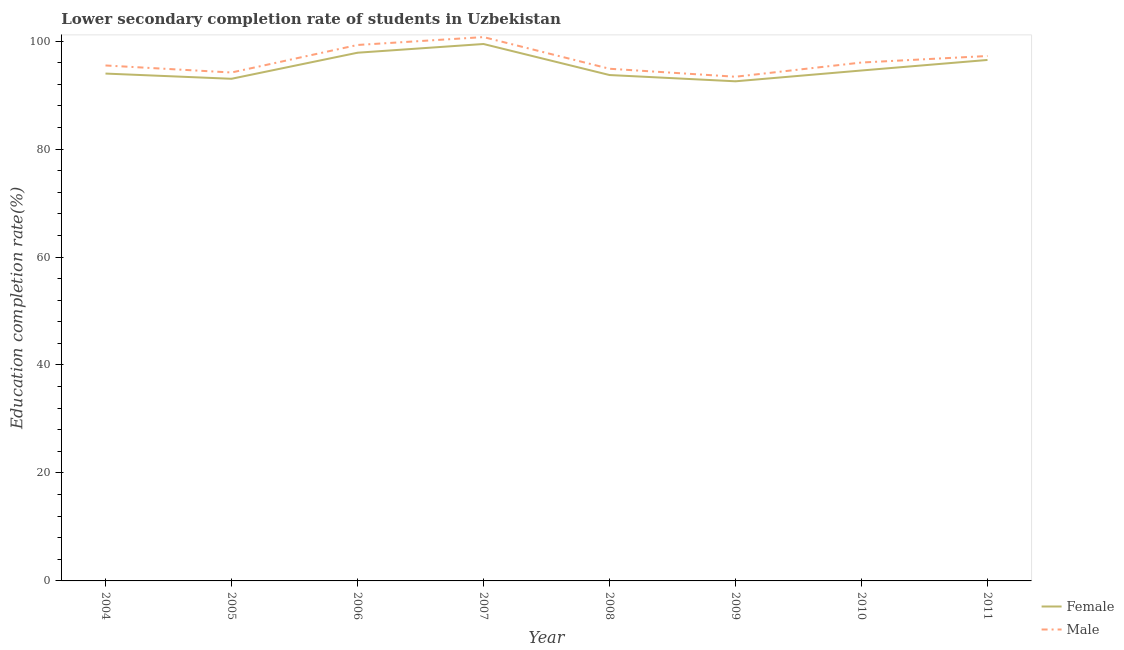How many different coloured lines are there?
Provide a succinct answer. 2. What is the education completion rate of female students in 2004?
Provide a short and direct response. 93.98. Across all years, what is the maximum education completion rate of female students?
Your response must be concise. 99.46. Across all years, what is the minimum education completion rate of female students?
Provide a succinct answer. 92.55. What is the total education completion rate of female students in the graph?
Make the answer very short. 761.59. What is the difference between the education completion rate of female students in 2010 and that in 2011?
Ensure brevity in your answer.  -1.95. What is the difference between the education completion rate of female students in 2004 and the education completion rate of male students in 2008?
Your answer should be compact. -0.89. What is the average education completion rate of female students per year?
Ensure brevity in your answer.  95.2. In the year 2006, what is the difference between the education completion rate of male students and education completion rate of female students?
Ensure brevity in your answer.  1.43. What is the ratio of the education completion rate of male students in 2004 to that in 2010?
Give a very brief answer. 0.99. Is the education completion rate of male students in 2007 less than that in 2009?
Keep it short and to the point. No. What is the difference between the highest and the second highest education completion rate of female students?
Keep it short and to the point. 1.62. What is the difference between the highest and the lowest education completion rate of male students?
Give a very brief answer. 7.34. Is the sum of the education completion rate of male students in 2006 and 2010 greater than the maximum education completion rate of female students across all years?
Your response must be concise. Yes. Does the education completion rate of female students monotonically increase over the years?
Provide a short and direct response. No. Is the education completion rate of male students strictly greater than the education completion rate of female students over the years?
Keep it short and to the point. Yes. How many lines are there?
Give a very brief answer. 2. How many years are there in the graph?
Provide a short and direct response. 8. What is the difference between two consecutive major ticks on the Y-axis?
Keep it short and to the point. 20. Where does the legend appear in the graph?
Your answer should be very brief. Bottom right. What is the title of the graph?
Your answer should be compact. Lower secondary completion rate of students in Uzbekistan. Does "Chemicals" appear as one of the legend labels in the graph?
Offer a terse response. No. What is the label or title of the X-axis?
Your response must be concise. Year. What is the label or title of the Y-axis?
Keep it short and to the point. Education completion rate(%). What is the Education completion rate(%) of Female in 2004?
Keep it short and to the point. 93.98. What is the Education completion rate(%) of Male in 2004?
Your answer should be compact. 95.48. What is the Education completion rate(%) of Female in 2005?
Provide a succinct answer. 93.01. What is the Education completion rate(%) in Male in 2005?
Provide a short and direct response. 94.18. What is the Education completion rate(%) in Female in 2006?
Provide a short and direct response. 97.84. What is the Education completion rate(%) in Male in 2006?
Your answer should be compact. 99.27. What is the Education completion rate(%) in Female in 2007?
Give a very brief answer. 99.46. What is the Education completion rate(%) in Male in 2007?
Provide a short and direct response. 100.74. What is the Education completion rate(%) in Female in 2008?
Give a very brief answer. 93.71. What is the Education completion rate(%) of Male in 2008?
Your answer should be very brief. 94.87. What is the Education completion rate(%) of Female in 2009?
Keep it short and to the point. 92.55. What is the Education completion rate(%) of Male in 2009?
Offer a terse response. 93.39. What is the Education completion rate(%) of Female in 2010?
Your answer should be compact. 94.55. What is the Education completion rate(%) of Male in 2010?
Provide a short and direct response. 96.02. What is the Education completion rate(%) in Female in 2011?
Your answer should be compact. 96.5. What is the Education completion rate(%) in Male in 2011?
Keep it short and to the point. 97.23. Across all years, what is the maximum Education completion rate(%) of Female?
Provide a succinct answer. 99.46. Across all years, what is the maximum Education completion rate(%) in Male?
Make the answer very short. 100.74. Across all years, what is the minimum Education completion rate(%) in Female?
Offer a terse response. 92.55. Across all years, what is the minimum Education completion rate(%) in Male?
Your response must be concise. 93.39. What is the total Education completion rate(%) of Female in the graph?
Ensure brevity in your answer.  761.59. What is the total Education completion rate(%) of Male in the graph?
Provide a succinct answer. 771.19. What is the difference between the Education completion rate(%) in Female in 2004 and that in 2005?
Ensure brevity in your answer.  0.97. What is the difference between the Education completion rate(%) of Male in 2004 and that in 2005?
Ensure brevity in your answer.  1.3. What is the difference between the Education completion rate(%) in Female in 2004 and that in 2006?
Offer a very short reply. -3.86. What is the difference between the Education completion rate(%) in Male in 2004 and that in 2006?
Keep it short and to the point. -3.79. What is the difference between the Education completion rate(%) of Female in 2004 and that in 2007?
Make the answer very short. -5.48. What is the difference between the Education completion rate(%) of Male in 2004 and that in 2007?
Give a very brief answer. -5.26. What is the difference between the Education completion rate(%) in Female in 2004 and that in 2008?
Make the answer very short. 0.27. What is the difference between the Education completion rate(%) of Male in 2004 and that in 2008?
Your answer should be compact. 0.61. What is the difference between the Education completion rate(%) of Female in 2004 and that in 2009?
Make the answer very short. 1.43. What is the difference between the Education completion rate(%) of Male in 2004 and that in 2009?
Make the answer very short. 2.09. What is the difference between the Education completion rate(%) in Female in 2004 and that in 2010?
Your answer should be very brief. -0.57. What is the difference between the Education completion rate(%) of Male in 2004 and that in 2010?
Provide a succinct answer. -0.54. What is the difference between the Education completion rate(%) of Female in 2004 and that in 2011?
Ensure brevity in your answer.  -2.52. What is the difference between the Education completion rate(%) in Male in 2004 and that in 2011?
Your answer should be compact. -1.75. What is the difference between the Education completion rate(%) in Female in 2005 and that in 2006?
Give a very brief answer. -4.83. What is the difference between the Education completion rate(%) in Male in 2005 and that in 2006?
Your response must be concise. -5.1. What is the difference between the Education completion rate(%) in Female in 2005 and that in 2007?
Your response must be concise. -6.44. What is the difference between the Education completion rate(%) of Male in 2005 and that in 2007?
Your answer should be very brief. -6.56. What is the difference between the Education completion rate(%) of Female in 2005 and that in 2008?
Your response must be concise. -0.69. What is the difference between the Education completion rate(%) in Male in 2005 and that in 2008?
Your answer should be compact. -0.7. What is the difference between the Education completion rate(%) in Female in 2005 and that in 2009?
Offer a very short reply. 0.47. What is the difference between the Education completion rate(%) in Male in 2005 and that in 2009?
Ensure brevity in your answer.  0.78. What is the difference between the Education completion rate(%) of Female in 2005 and that in 2010?
Offer a very short reply. -1.54. What is the difference between the Education completion rate(%) in Male in 2005 and that in 2010?
Your answer should be very brief. -1.85. What is the difference between the Education completion rate(%) of Female in 2005 and that in 2011?
Offer a terse response. -3.49. What is the difference between the Education completion rate(%) in Male in 2005 and that in 2011?
Offer a very short reply. -3.06. What is the difference between the Education completion rate(%) of Female in 2006 and that in 2007?
Your response must be concise. -1.62. What is the difference between the Education completion rate(%) of Male in 2006 and that in 2007?
Provide a short and direct response. -1.46. What is the difference between the Education completion rate(%) in Female in 2006 and that in 2008?
Offer a terse response. 4.13. What is the difference between the Education completion rate(%) of Male in 2006 and that in 2008?
Give a very brief answer. 4.4. What is the difference between the Education completion rate(%) of Female in 2006 and that in 2009?
Ensure brevity in your answer.  5.29. What is the difference between the Education completion rate(%) in Male in 2006 and that in 2009?
Make the answer very short. 5.88. What is the difference between the Education completion rate(%) in Female in 2006 and that in 2010?
Give a very brief answer. 3.29. What is the difference between the Education completion rate(%) in Male in 2006 and that in 2010?
Your response must be concise. 3.25. What is the difference between the Education completion rate(%) in Female in 2006 and that in 2011?
Keep it short and to the point. 1.34. What is the difference between the Education completion rate(%) of Male in 2006 and that in 2011?
Your answer should be compact. 2.04. What is the difference between the Education completion rate(%) of Female in 2007 and that in 2008?
Give a very brief answer. 5.75. What is the difference between the Education completion rate(%) in Male in 2007 and that in 2008?
Your answer should be compact. 5.87. What is the difference between the Education completion rate(%) of Female in 2007 and that in 2009?
Offer a very short reply. 6.91. What is the difference between the Education completion rate(%) in Male in 2007 and that in 2009?
Your response must be concise. 7.34. What is the difference between the Education completion rate(%) in Female in 2007 and that in 2010?
Offer a terse response. 4.91. What is the difference between the Education completion rate(%) of Male in 2007 and that in 2010?
Offer a very short reply. 4.71. What is the difference between the Education completion rate(%) of Female in 2007 and that in 2011?
Keep it short and to the point. 2.95. What is the difference between the Education completion rate(%) of Male in 2007 and that in 2011?
Make the answer very short. 3.5. What is the difference between the Education completion rate(%) of Female in 2008 and that in 2009?
Offer a very short reply. 1.16. What is the difference between the Education completion rate(%) of Male in 2008 and that in 2009?
Give a very brief answer. 1.48. What is the difference between the Education completion rate(%) in Female in 2008 and that in 2010?
Your response must be concise. -0.84. What is the difference between the Education completion rate(%) in Male in 2008 and that in 2010?
Your answer should be very brief. -1.15. What is the difference between the Education completion rate(%) in Female in 2008 and that in 2011?
Your response must be concise. -2.79. What is the difference between the Education completion rate(%) of Male in 2008 and that in 2011?
Provide a succinct answer. -2.36. What is the difference between the Education completion rate(%) of Female in 2009 and that in 2010?
Your response must be concise. -2. What is the difference between the Education completion rate(%) of Male in 2009 and that in 2010?
Your answer should be compact. -2.63. What is the difference between the Education completion rate(%) of Female in 2009 and that in 2011?
Your answer should be very brief. -3.95. What is the difference between the Education completion rate(%) of Male in 2009 and that in 2011?
Give a very brief answer. -3.84. What is the difference between the Education completion rate(%) in Female in 2010 and that in 2011?
Your answer should be very brief. -1.95. What is the difference between the Education completion rate(%) in Male in 2010 and that in 2011?
Make the answer very short. -1.21. What is the difference between the Education completion rate(%) of Female in 2004 and the Education completion rate(%) of Male in 2005?
Ensure brevity in your answer.  -0.2. What is the difference between the Education completion rate(%) of Female in 2004 and the Education completion rate(%) of Male in 2006?
Keep it short and to the point. -5.3. What is the difference between the Education completion rate(%) in Female in 2004 and the Education completion rate(%) in Male in 2007?
Give a very brief answer. -6.76. What is the difference between the Education completion rate(%) of Female in 2004 and the Education completion rate(%) of Male in 2008?
Provide a short and direct response. -0.89. What is the difference between the Education completion rate(%) in Female in 2004 and the Education completion rate(%) in Male in 2009?
Your answer should be very brief. 0.59. What is the difference between the Education completion rate(%) of Female in 2004 and the Education completion rate(%) of Male in 2010?
Provide a succinct answer. -2.05. What is the difference between the Education completion rate(%) of Female in 2004 and the Education completion rate(%) of Male in 2011?
Your response must be concise. -3.25. What is the difference between the Education completion rate(%) in Female in 2005 and the Education completion rate(%) in Male in 2006?
Give a very brief answer. -6.26. What is the difference between the Education completion rate(%) of Female in 2005 and the Education completion rate(%) of Male in 2007?
Provide a short and direct response. -7.72. What is the difference between the Education completion rate(%) in Female in 2005 and the Education completion rate(%) in Male in 2008?
Offer a terse response. -1.86. What is the difference between the Education completion rate(%) in Female in 2005 and the Education completion rate(%) in Male in 2009?
Provide a short and direct response. -0.38. What is the difference between the Education completion rate(%) of Female in 2005 and the Education completion rate(%) of Male in 2010?
Ensure brevity in your answer.  -3.01. What is the difference between the Education completion rate(%) in Female in 2005 and the Education completion rate(%) in Male in 2011?
Ensure brevity in your answer.  -4.22. What is the difference between the Education completion rate(%) in Female in 2006 and the Education completion rate(%) in Male in 2007?
Keep it short and to the point. -2.9. What is the difference between the Education completion rate(%) in Female in 2006 and the Education completion rate(%) in Male in 2008?
Give a very brief answer. 2.97. What is the difference between the Education completion rate(%) in Female in 2006 and the Education completion rate(%) in Male in 2009?
Your response must be concise. 4.45. What is the difference between the Education completion rate(%) in Female in 2006 and the Education completion rate(%) in Male in 2010?
Provide a succinct answer. 1.82. What is the difference between the Education completion rate(%) in Female in 2006 and the Education completion rate(%) in Male in 2011?
Offer a very short reply. 0.61. What is the difference between the Education completion rate(%) of Female in 2007 and the Education completion rate(%) of Male in 2008?
Give a very brief answer. 4.58. What is the difference between the Education completion rate(%) of Female in 2007 and the Education completion rate(%) of Male in 2009?
Ensure brevity in your answer.  6.06. What is the difference between the Education completion rate(%) in Female in 2007 and the Education completion rate(%) in Male in 2010?
Offer a terse response. 3.43. What is the difference between the Education completion rate(%) of Female in 2007 and the Education completion rate(%) of Male in 2011?
Make the answer very short. 2.22. What is the difference between the Education completion rate(%) in Female in 2008 and the Education completion rate(%) in Male in 2009?
Your answer should be compact. 0.32. What is the difference between the Education completion rate(%) of Female in 2008 and the Education completion rate(%) of Male in 2010?
Keep it short and to the point. -2.32. What is the difference between the Education completion rate(%) of Female in 2008 and the Education completion rate(%) of Male in 2011?
Your answer should be compact. -3.53. What is the difference between the Education completion rate(%) in Female in 2009 and the Education completion rate(%) in Male in 2010?
Provide a short and direct response. -3.48. What is the difference between the Education completion rate(%) of Female in 2009 and the Education completion rate(%) of Male in 2011?
Provide a succinct answer. -4.69. What is the difference between the Education completion rate(%) of Female in 2010 and the Education completion rate(%) of Male in 2011?
Provide a succinct answer. -2.68. What is the average Education completion rate(%) in Female per year?
Your response must be concise. 95.2. What is the average Education completion rate(%) in Male per year?
Provide a succinct answer. 96.4. In the year 2004, what is the difference between the Education completion rate(%) in Female and Education completion rate(%) in Male?
Offer a terse response. -1.5. In the year 2005, what is the difference between the Education completion rate(%) in Female and Education completion rate(%) in Male?
Ensure brevity in your answer.  -1.16. In the year 2006, what is the difference between the Education completion rate(%) of Female and Education completion rate(%) of Male?
Ensure brevity in your answer.  -1.43. In the year 2007, what is the difference between the Education completion rate(%) in Female and Education completion rate(%) in Male?
Provide a succinct answer. -1.28. In the year 2008, what is the difference between the Education completion rate(%) in Female and Education completion rate(%) in Male?
Ensure brevity in your answer.  -1.16. In the year 2009, what is the difference between the Education completion rate(%) of Female and Education completion rate(%) of Male?
Give a very brief answer. -0.84. In the year 2010, what is the difference between the Education completion rate(%) in Female and Education completion rate(%) in Male?
Give a very brief answer. -1.48. In the year 2011, what is the difference between the Education completion rate(%) of Female and Education completion rate(%) of Male?
Your answer should be compact. -0.73. What is the ratio of the Education completion rate(%) in Female in 2004 to that in 2005?
Make the answer very short. 1.01. What is the ratio of the Education completion rate(%) in Male in 2004 to that in 2005?
Offer a very short reply. 1.01. What is the ratio of the Education completion rate(%) of Female in 2004 to that in 2006?
Offer a very short reply. 0.96. What is the ratio of the Education completion rate(%) in Male in 2004 to that in 2006?
Offer a terse response. 0.96. What is the ratio of the Education completion rate(%) of Female in 2004 to that in 2007?
Make the answer very short. 0.94. What is the ratio of the Education completion rate(%) of Male in 2004 to that in 2007?
Make the answer very short. 0.95. What is the ratio of the Education completion rate(%) of Male in 2004 to that in 2008?
Provide a succinct answer. 1.01. What is the ratio of the Education completion rate(%) in Female in 2004 to that in 2009?
Your answer should be very brief. 1.02. What is the ratio of the Education completion rate(%) of Male in 2004 to that in 2009?
Offer a terse response. 1.02. What is the ratio of the Education completion rate(%) in Male in 2004 to that in 2010?
Make the answer very short. 0.99. What is the ratio of the Education completion rate(%) in Female in 2004 to that in 2011?
Provide a succinct answer. 0.97. What is the ratio of the Education completion rate(%) in Female in 2005 to that in 2006?
Your response must be concise. 0.95. What is the ratio of the Education completion rate(%) in Male in 2005 to that in 2006?
Your answer should be very brief. 0.95. What is the ratio of the Education completion rate(%) of Female in 2005 to that in 2007?
Provide a succinct answer. 0.94. What is the ratio of the Education completion rate(%) of Male in 2005 to that in 2007?
Your response must be concise. 0.93. What is the ratio of the Education completion rate(%) in Female in 2005 to that in 2008?
Give a very brief answer. 0.99. What is the ratio of the Education completion rate(%) in Female in 2005 to that in 2009?
Ensure brevity in your answer.  1. What is the ratio of the Education completion rate(%) in Male in 2005 to that in 2009?
Your answer should be very brief. 1.01. What is the ratio of the Education completion rate(%) of Female in 2005 to that in 2010?
Your response must be concise. 0.98. What is the ratio of the Education completion rate(%) of Male in 2005 to that in 2010?
Provide a short and direct response. 0.98. What is the ratio of the Education completion rate(%) of Female in 2005 to that in 2011?
Offer a very short reply. 0.96. What is the ratio of the Education completion rate(%) of Male in 2005 to that in 2011?
Offer a very short reply. 0.97. What is the ratio of the Education completion rate(%) in Female in 2006 to that in 2007?
Give a very brief answer. 0.98. What is the ratio of the Education completion rate(%) of Male in 2006 to that in 2007?
Keep it short and to the point. 0.99. What is the ratio of the Education completion rate(%) of Female in 2006 to that in 2008?
Offer a terse response. 1.04. What is the ratio of the Education completion rate(%) in Male in 2006 to that in 2008?
Ensure brevity in your answer.  1.05. What is the ratio of the Education completion rate(%) in Female in 2006 to that in 2009?
Ensure brevity in your answer.  1.06. What is the ratio of the Education completion rate(%) in Male in 2006 to that in 2009?
Ensure brevity in your answer.  1.06. What is the ratio of the Education completion rate(%) in Female in 2006 to that in 2010?
Offer a terse response. 1.03. What is the ratio of the Education completion rate(%) in Male in 2006 to that in 2010?
Your answer should be compact. 1.03. What is the ratio of the Education completion rate(%) of Female in 2006 to that in 2011?
Make the answer very short. 1.01. What is the ratio of the Education completion rate(%) of Female in 2007 to that in 2008?
Give a very brief answer. 1.06. What is the ratio of the Education completion rate(%) in Male in 2007 to that in 2008?
Offer a very short reply. 1.06. What is the ratio of the Education completion rate(%) of Female in 2007 to that in 2009?
Keep it short and to the point. 1.07. What is the ratio of the Education completion rate(%) of Male in 2007 to that in 2009?
Your answer should be very brief. 1.08. What is the ratio of the Education completion rate(%) in Female in 2007 to that in 2010?
Ensure brevity in your answer.  1.05. What is the ratio of the Education completion rate(%) of Male in 2007 to that in 2010?
Ensure brevity in your answer.  1.05. What is the ratio of the Education completion rate(%) of Female in 2007 to that in 2011?
Provide a short and direct response. 1.03. What is the ratio of the Education completion rate(%) in Male in 2007 to that in 2011?
Provide a short and direct response. 1.04. What is the ratio of the Education completion rate(%) of Female in 2008 to that in 2009?
Offer a very short reply. 1.01. What is the ratio of the Education completion rate(%) in Male in 2008 to that in 2009?
Give a very brief answer. 1.02. What is the ratio of the Education completion rate(%) in Female in 2008 to that in 2011?
Make the answer very short. 0.97. What is the ratio of the Education completion rate(%) in Male in 2008 to that in 2011?
Your answer should be compact. 0.98. What is the ratio of the Education completion rate(%) in Female in 2009 to that in 2010?
Your answer should be compact. 0.98. What is the ratio of the Education completion rate(%) in Male in 2009 to that in 2010?
Make the answer very short. 0.97. What is the ratio of the Education completion rate(%) in Female in 2009 to that in 2011?
Your response must be concise. 0.96. What is the ratio of the Education completion rate(%) of Male in 2009 to that in 2011?
Your response must be concise. 0.96. What is the ratio of the Education completion rate(%) of Female in 2010 to that in 2011?
Your answer should be very brief. 0.98. What is the ratio of the Education completion rate(%) of Male in 2010 to that in 2011?
Make the answer very short. 0.99. What is the difference between the highest and the second highest Education completion rate(%) in Female?
Ensure brevity in your answer.  1.62. What is the difference between the highest and the second highest Education completion rate(%) of Male?
Your response must be concise. 1.46. What is the difference between the highest and the lowest Education completion rate(%) in Female?
Give a very brief answer. 6.91. What is the difference between the highest and the lowest Education completion rate(%) in Male?
Your response must be concise. 7.34. 